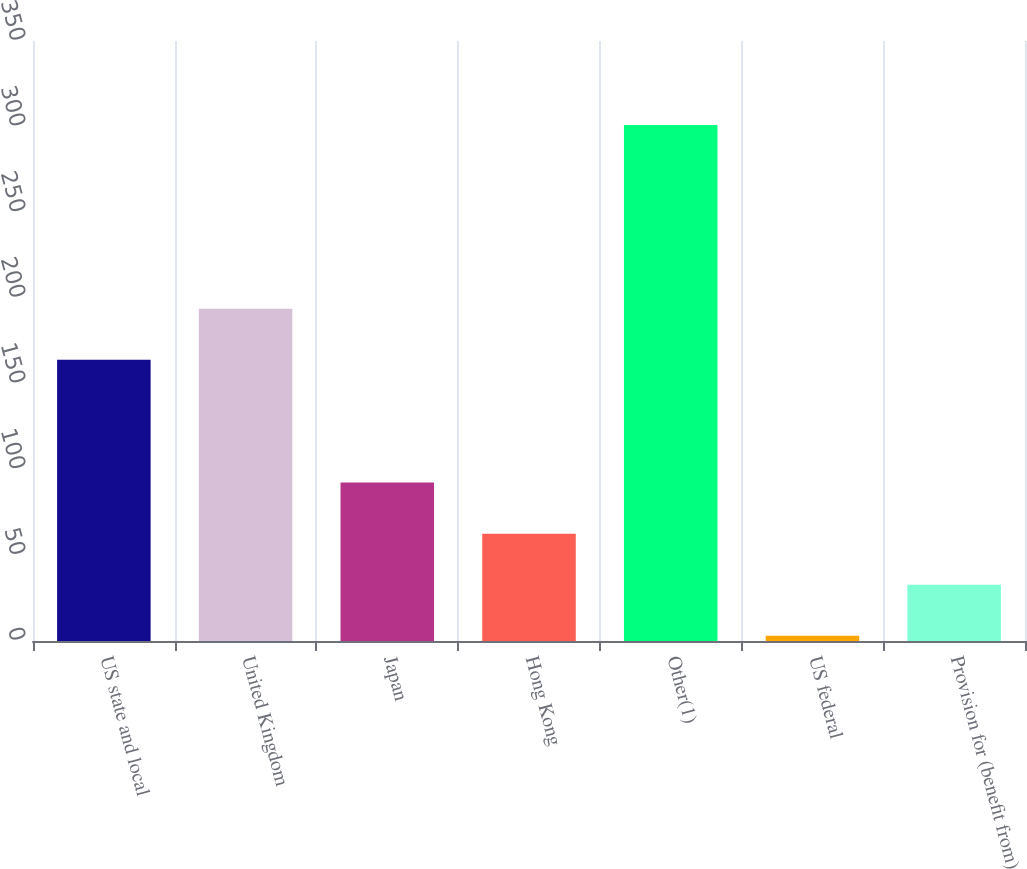Convert chart to OTSL. <chart><loc_0><loc_0><loc_500><loc_500><bar_chart><fcel>US state and local<fcel>United Kingdom<fcel>Japan<fcel>Hong Kong<fcel>Other(1)<fcel>US federal<fcel>Provision for (benefit from)<nl><fcel>164<fcel>193.8<fcel>92.4<fcel>62.6<fcel>301<fcel>3<fcel>32.8<nl></chart> 